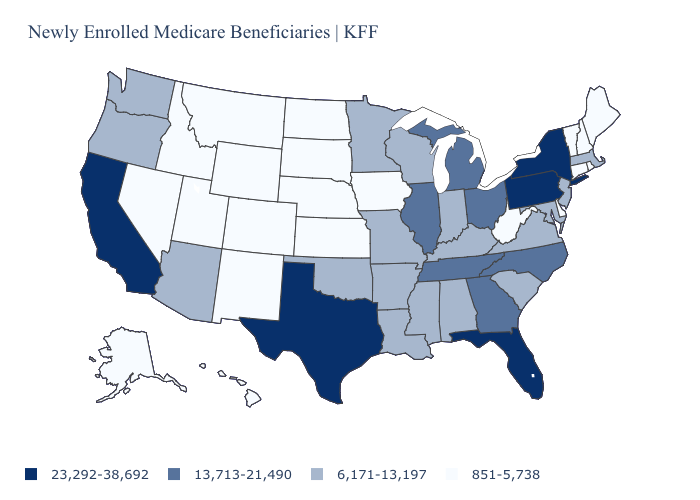Which states hav the highest value in the Northeast?
Keep it brief. New York, Pennsylvania. Which states have the highest value in the USA?
Answer briefly. California, Florida, New York, Pennsylvania, Texas. Which states hav the highest value in the South?
Short answer required. Florida, Texas. What is the lowest value in the USA?
Short answer required. 851-5,738. What is the value of Tennessee?
Quick response, please. 13,713-21,490. Name the states that have a value in the range 851-5,738?
Short answer required. Alaska, Colorado, Connecticut, Delaware, Hawaii, Idaho, Iowa, Kansas, Maine, Montana, Nebraska, Nevada, New Hampshire, New Mexico, North Dakota, Rhode Island, South Dakota, Utah, Vermont, West Virginia, Wyoming. Name the states that have a value in the range 6,171-13,197?
Write a very short answer. Alabama, Arizona, Arkansas, Indiana, Kentucky, Louisiana, Maryland, Massachusetts, Minnesota, Mississippi, Missouri, New Jersey, Oklahoma, Oregon, South Carolina, Virginia, Washington, Wisconsin. What is the value of Tennessee?
Concise answer only. 13,713-21,490. Does the first symbol in the legend represent the smallest category?
Write a very short answer. No. Does Pennsylvania have the same value as Oregon?
Quick response, please. No. Name the states that have a value in the range 6,171-13,197?
Be succinct. Alabama, Arizona, Arkansas, Indiana, Kentucky, Louisiana, Maryland, Massachusetts, Minnesota, Mississippi, Missouri, New Jersey, Oklahoma, Oregon, South Carolina, Virginia, Washington, Wisconsin. How many symbols are there in the legend?
Write a very short answer. 4. Does Kansas have a higher value than Wisconsin?
Short answer required. No. Which states have the lowest value in the West?
Be succinct. Alaska, Colorado, Hawaii, Idaho, Montana, Nevada, New Mexico, Utah, Wyoming. Name the states that have a value in the range 851-5,738?
Be succinct. Alaska, Colorado, Connecticut, Delaware, Hawaii, Idaho, Iowa, Kansas, Maine, Montana, Nebraska, Nevada, New Hampshire, New Mexico, North Dakota, Rhode Island, South Dakota, Utah, Vermont, West Virginia, Wyoming. 